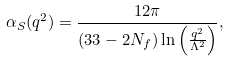Convert formula to latex. <formula><loc_0><loc_0><loc_500><loc_500>\alpha _ { S } ( q ^ { 2 } ) = \frac { 1 2 \pi } { ( 3 3 - 2 N _ { f } ) \ln \left ( \frac { q ^ { 2 } } { \Lambda ^ { 2 } } \right ) } ,</formula> 